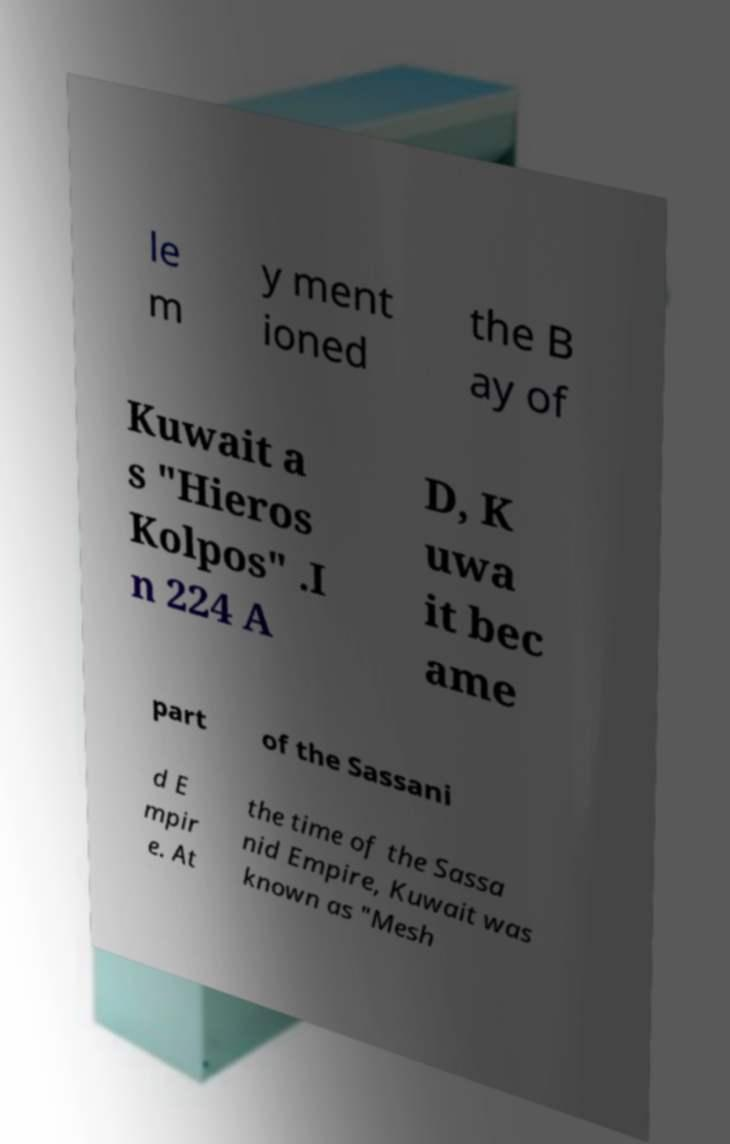Could you extract and type out the text from this image? le m y ment ioned the B ay of Kuwait a s "Hieros Kolpos" .I n 224 A D, K uwa it bec ame part of the Sassani d E mpir e. At the time of the Sassa nid Empire, Kuwait was known as "Mesh 